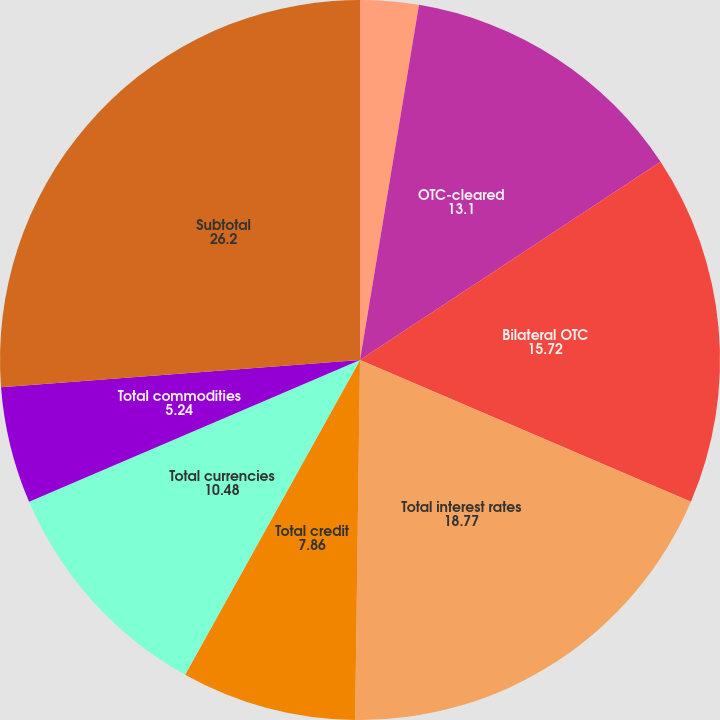Convert chart to OTSL. <chart><loc_0><loc_0><loc_500><loc_500><pie_chart><fcel>Exchange-traded<fcel>OTC-cleared<fcel>Bilateral OTC<fcel>Total interest rates<fcel>Total credit<fcel>Total currencies<fcel>Total commodities<fcel>Subtotal<fcel>Derivatives accounted for as<nl><fcel>2.62%<fcel>13.1%<fcel>15.72%<fcel>18.77%<fcel>7.86%<fcel>10.48%<fcel>5.24%<fcel>26.2%<fcel>0.0%<nl></chart> 